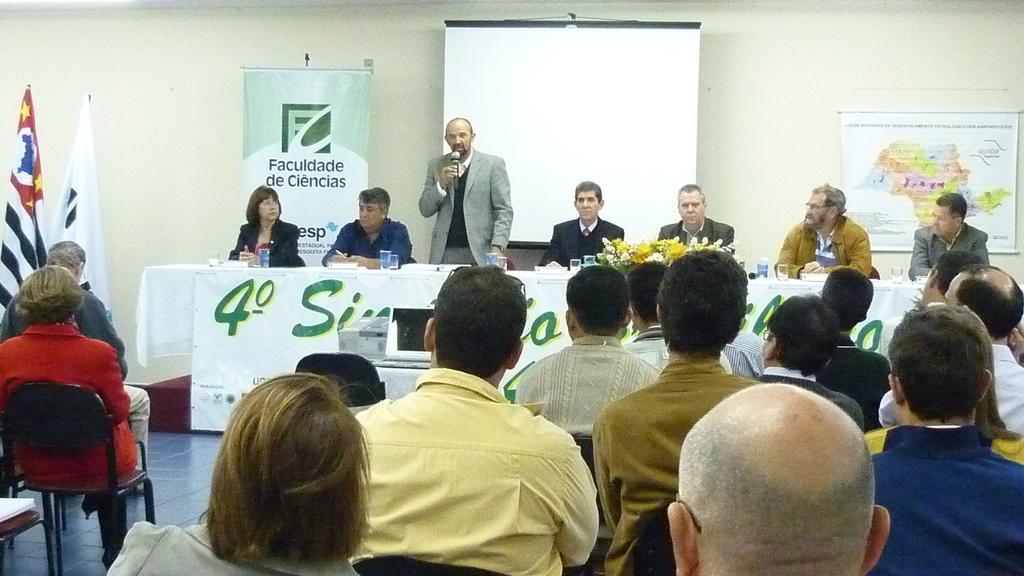Describe this image in one or two sentences. In this image i can see a group of people sitting on a chair at the back ground i can see a few people sitting and a man standing holding a micro phone, a projector, a banner and a wall. 